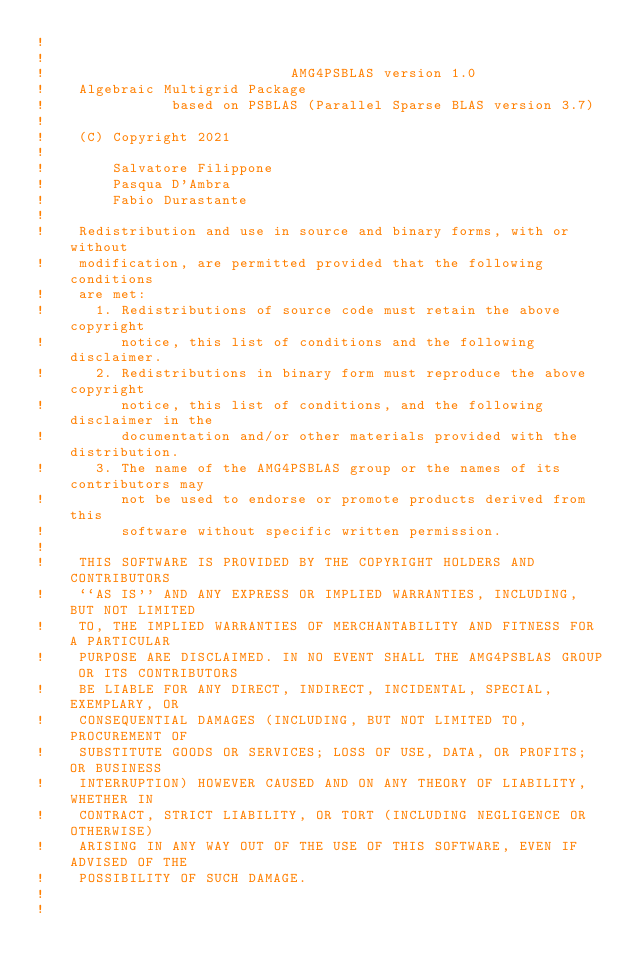Convert code to text. <code><loc_0><loc_0><loc_500><loc_500><_FORTRAN_>!  
!   
!                             AMG4PSBLAS version 1.0
!    Algebraic Multigrid Package
!               based on PSBLAS (Parallel Sparse BLAS version 3.7)
!    
!    (C) Copyright 2021 
!  
!        Salvatore Filippone  
!        Pasqua D'Ambra   
!        Fabio Durastante        
!   
!    Redistribution and use in source and binary forms, with or without
!    modification, are permitted provided that the following conditions
!    are met:
!      1. Redistributions of source code must retain the above copyright
!         notice, this list of conditions and the following disclaimer.
!      2. Redistributions in binary form must reproduce the above copyright
!         notice, this list of conditions, and the following disclaimer in the
!         documentation and/or other materials provided with the distribution.
!      3. The name of the AMG4PSBLAS group or the names of its contributors may
!         not be used to endorse or promote products derived from this
!         software without specific written permission.
!   
!    THIS SOFTWARE IS PROVIDED BY THE COPYRIGHT HOLDERS AND CONTRIBUTORS
!    ``AS IS'' AND ANY EXPRESS OR IMPLIED WARRANTIES, INCLUDING, BUT NOT LIMITED
!    TO, THE IMPLIED WARRANTIES OF MERCHANTABILITY AND FITNESS FOR A PARTICULAR
!    PURPOSE ARE DISCLAIMED. IN NO EVENT SHALL THE AMG4PSBLAS GROUP OR ITS CONTRIBUTORS
!    BE LIABLE FOR ANY DIRECT, INDIRECT, INCIDENTAL, SPECIAL, EXEMPLARY, OR
!    CONSEQUENTIAL DAMAGES (INCLUDING, BUT NOT LIMITED TO, PROCUREMENT OF
!    SUBSTITUTE GOODS OR SERVICES; LOSS OF USE, DATA, OR PROFITS; OR BUSINESS
!    INTERRUPTION) HOWEVER CAUSED AND ON ANY THEORY OF LIABILITY, WHETHER IN
!    CONTRACT, STRICT LIABILITY, OR TORT (INCLUDING NEGLIGENCE OR OTHERWISE)
!    ARISING IN ANY WAY OUT OF THE USE OF THIS SOFTWARE, EVEN IF ADVISED OF THE
!    POSSIBILITY OF SUCH DAMAGE.
!   
!  </code> 